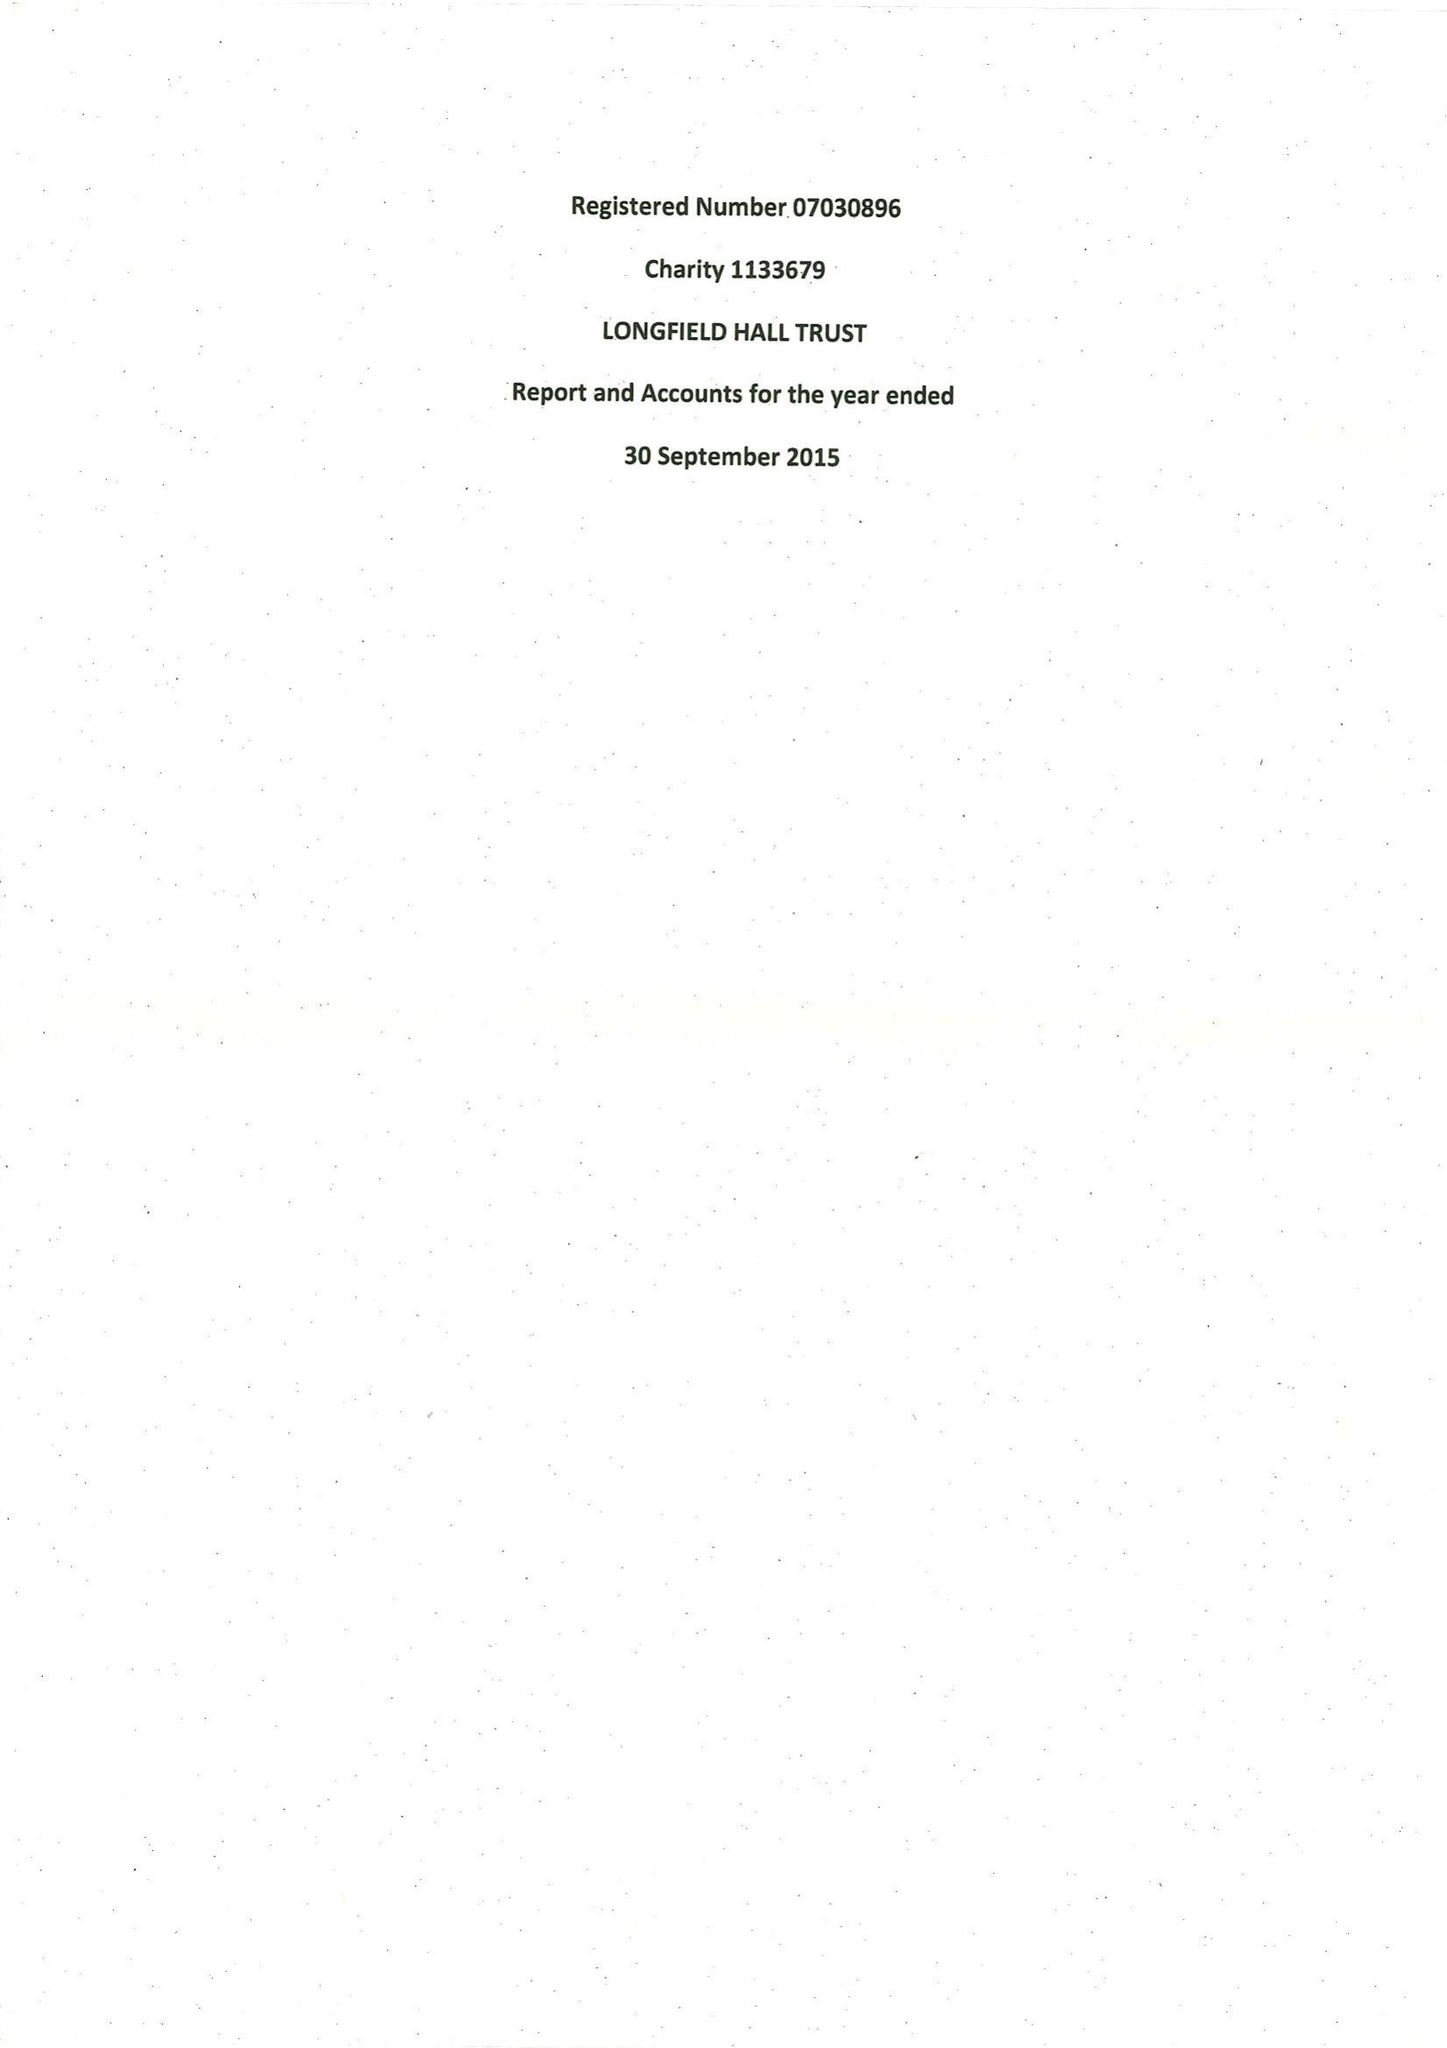What is the value for the charity_number?
Answer the question using a single word or phrase. 1133679 